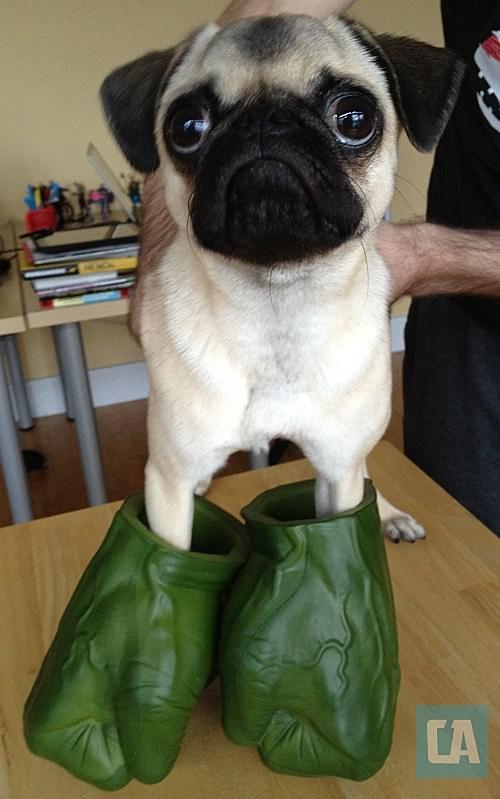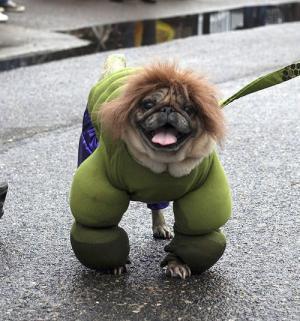The first image is the image on the left, the second image is the image on the right. Evaluate the accuracy of this statement regarding the images: "One image shows a pug with green-dyed fur wearing blue shorts and gazing toward the camera.". Is it true? Answer yes or no. No. The first image is the image on the left, the second image is the image on the right. Analyze the images presented: Is the assertion "A dog is showing its tongue in the right image." valid? Answer yes or no. Yes. 